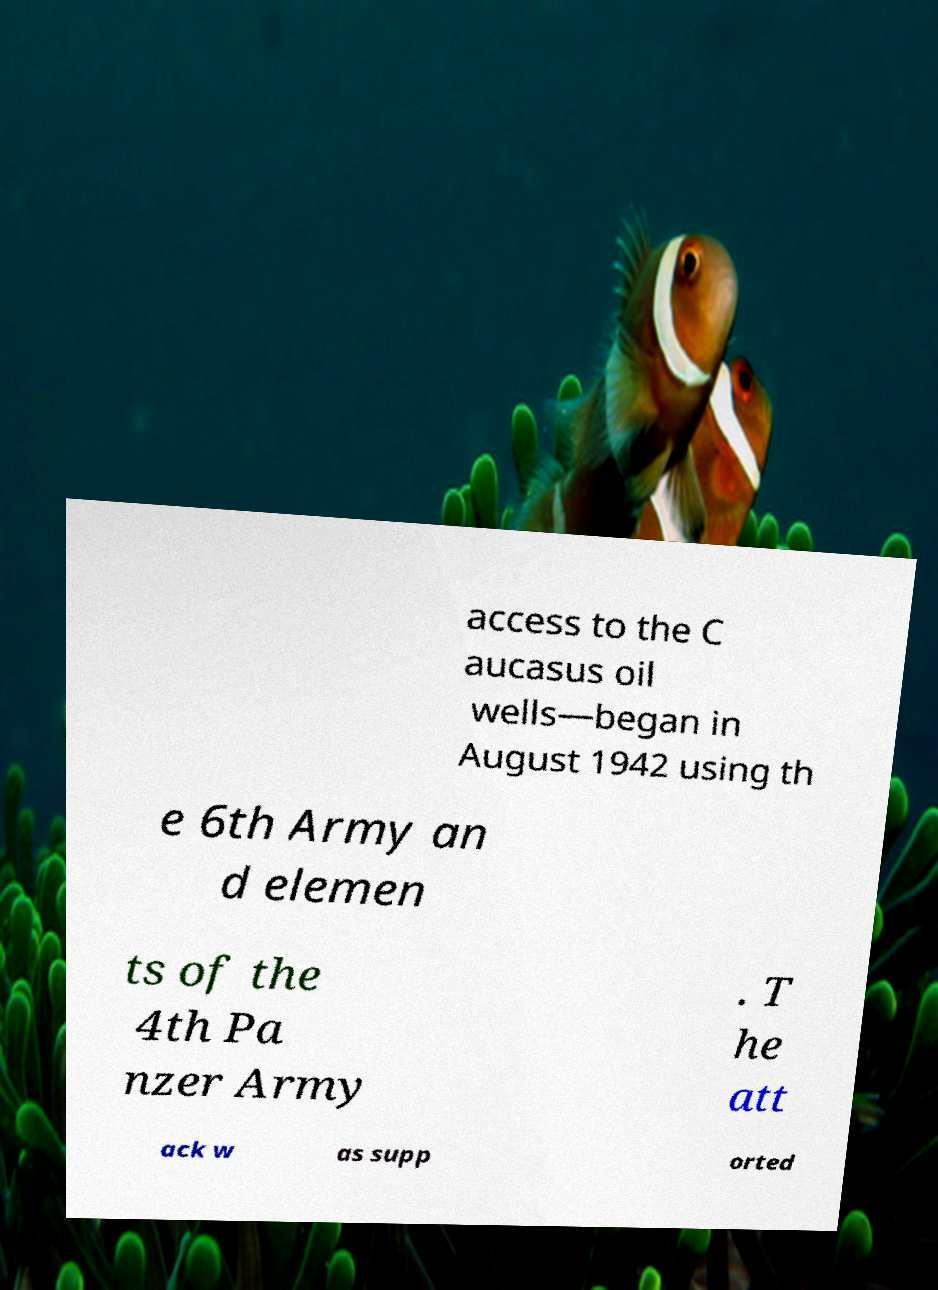Please read and relay the text visible in this image. What does it say? access to the C aucasus oil wells—began in August 1942 using th e 6th Army an d elemen ts of the 4th Pa nzer Army . T he att ack w as supp orted 